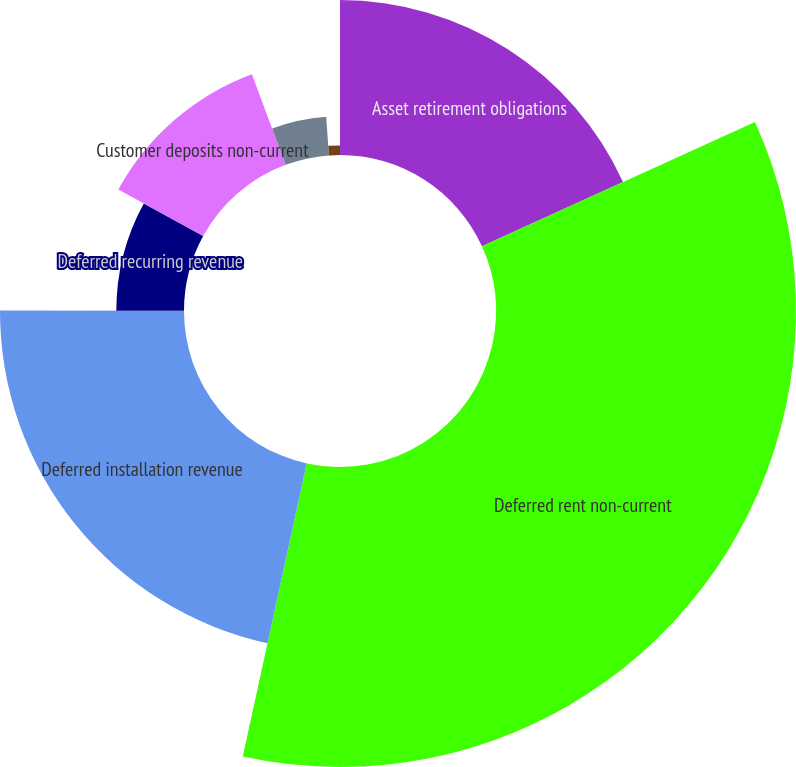Convert chart to OTSL. <chart><loc_0><loc_0><loc_500><loc_500><pie_chart><fcel>Asset retirement obligations<fcel>Deferred rent non-current<fcel>Deferred installation revenue<fcel>Deferred recurring revenue<fcel>Customer deposits non-current<fcel>Accrued restructuring charges<fcel>Other liabilities<nl><fcel>18.2%<fcel>35.23%<fcel>21.61%<fcel>7.95%<fcel>11.36%<fcel>4.54%<fcel>1.13%<nl></chart> 